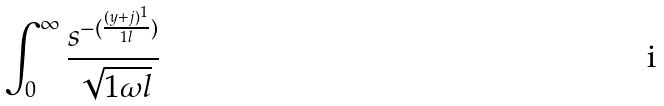<formula> <loc_0><loc_0><loc_500><loc_500>\int _ { 0 } ^ { \infty } \frac { s ^ { - ( \frac { ( y + j ) ^ { 1 } } { 1 l } ) } } { \sqrt { 1 \omega l } }</formula> 